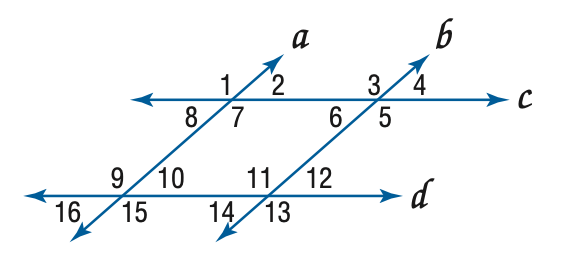Question: In the figure, a \parallel b, c \parallel d, and m \angle 4 = 57. Find the measure of \angle 5.
Choices:
A. 57
B. 113
C. 123
D. 133
Answer with the letter. Answer: C 